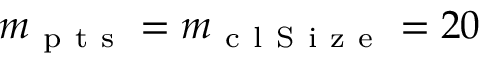<formula> <loc_0><loc_0><loc_500><loc_500>m _ { p t s } = m _ { c l S i z e } = 2 0</formula> 